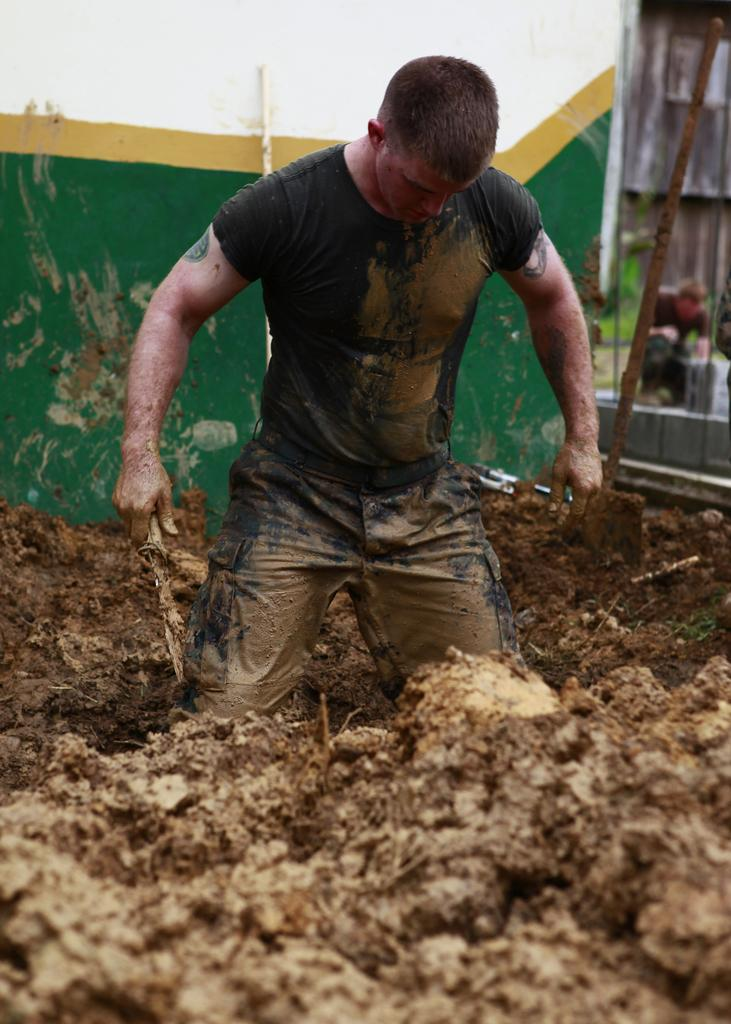What is the man in the image holding? The man is holding an object in the image. What type of terrain is visible in the image? There is mud visible in the image. Can you describe the person in the background of the image? There is a person in the background of the image. What can be seen behind the person in the background? There is a wall and other objects in the background of the image. What type of plastic material is being used by the family in the image? There is no mention of a family or plastic material in the image. 